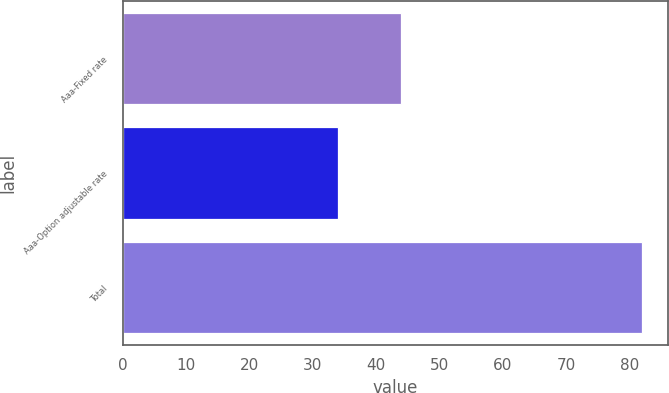Convert chart. <chart><loc_0><loc_0><loc_500><loc_500><bar_chart><fcel>Aaa-Fixed rate<fcel>Aaa-Option adjustable rate<fcel>Total<nl><fcel>44<fcel>34<fcel>82<nl></chart> 